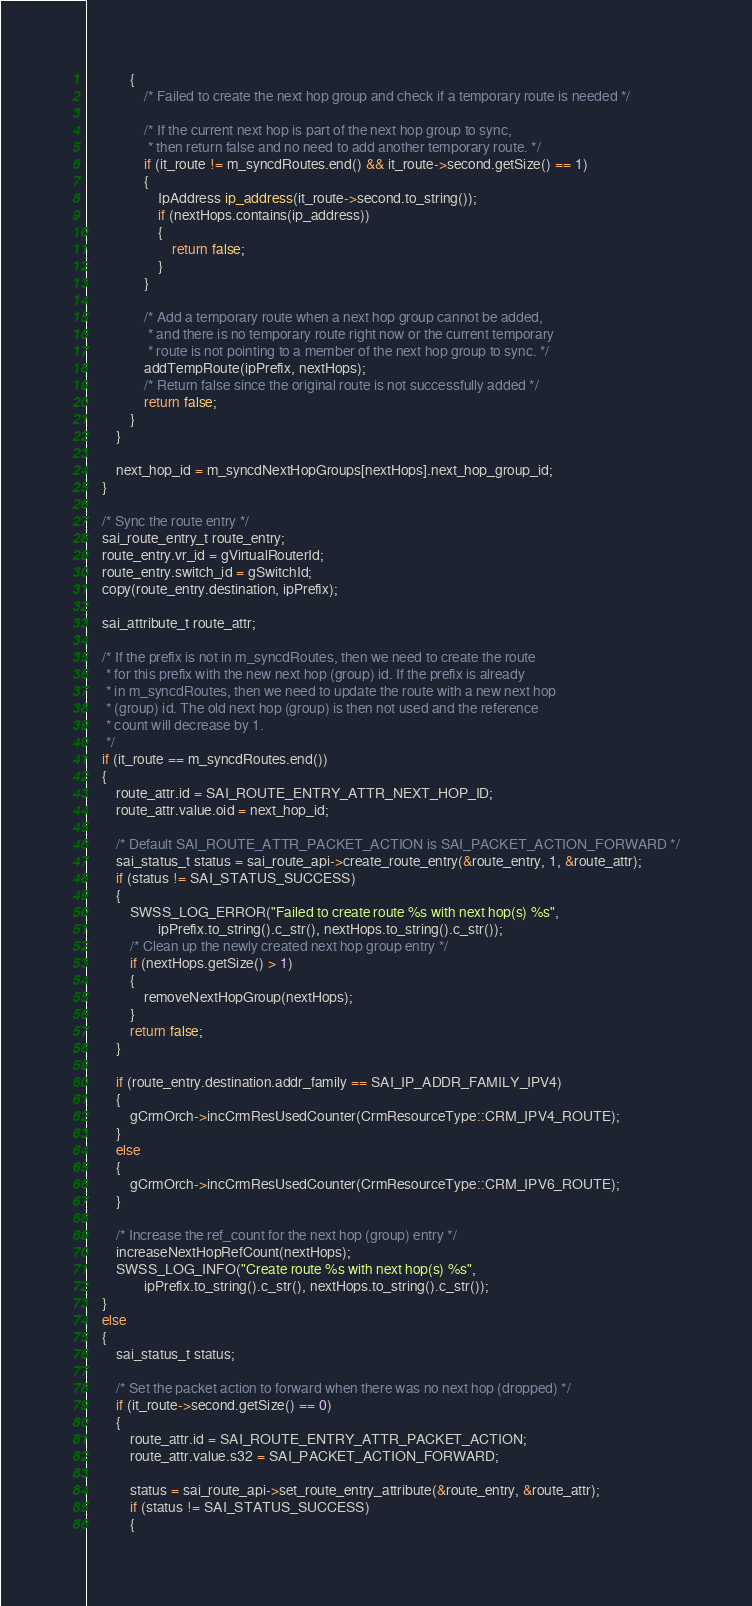Convert code to text. <code><loc_0><loc_0><loc_500><loc_500><_C++_>            {
                /* Failed to create the next hop group and check if a temporary route is needed */

                /* If the current next hop is part of the next hop group to sync,
                 * then return false and no need to add another temporary route. */
                if (it_route != m_syncdRoutes.end() && it_route->second.getSize() == 1)
                {
                    IpAddress ip_address(it_route->second.to_string());
                    if (nextHops.contains(ip_address))
                    {
                        return false;
                    }
                }

                /* Add a temporary route when a next hop group cannot be added,
                 * and there is no temporary route right now or the current temporary
                 * route is not pointing to a member of the next hop group to sync. */
                addTempRoute(ipPrefix, nextHops);
                /* Return false since the original route is not successfully added */
                return false;
            }
        }

        next_hop_id = m_syncdNextHopGroups[nextHops].next_hop_group_id;
    }

    /* Sync the route entry */
    sai_route_entry_t route_entry;
    route_entry.vr_id = gVirtualRouterId;
    route_entry.switch_id = gSwitchId;
    copy(route_entry.destination, ipPrefix);

    sai_attribute_t route_attr;

    /* If the prefix is not in m_syncdRoutes, then we need to create the route
     * for this prefix with the new next hop (group) id. If the prefix is already
     * in m_syncdRoutes, then we need to update the route with a new next hop
     * (group) id. The old next hop (group) is then not used and the reference
     * count will decrease by 1.
     */
    if (it_route == m_syncdRoutes.end())
    {
        route_attr.id = SAI_ROUTE_ENTRY_ATTR_NEXT_HOP_ID;
        route_attr.value.oid = next_hop_id;

        /* Default SAI_ROUTE_ATTR_PACKET_ACTION is SAI_PACKET_ACTION_FORWARD */
        sai_status_t status = sai_route_api->create_route_entry(&route_entry, 1, &route_attr);
        if (status != SAI_STATUS_SUCCESS)
        {
            SWSS_LOG_ERROR("Failed to create route %s with next hop(s) %s",
                    ipPrefix.to_string().c_str(), nextHops.to_string().c_str());
            /* Clean up the newly created next hop group entry */
            if (nextHops.getSize() > 1)
            {
                removeNextHopGroup(nextHops);
            }
            return false;
        }

        if (route_entry.destination.addr_family == SAI_IP_ADDR_FAMILY_IPV4)
        {
            gCrmOrch->incCrmResUsedCounter(CrmResourceType::CRM_IPV4_ROUTE);
        }
        else
        {
            gCrmOrch->incCrmResUsedCounter(CrmResourceType::CRM_IPV6_ROUTE);
        }

        /* Increase the ref_count for the next hop (group) entry */
        increaseNextHopRefCount(nextHops);
        SWSS_LOG_INFO("Create route %s with next hop(s) %s",
                ipPrefix.to_string().c_str(), nextHops.to_string().c_str());
    }
    else
    {
        sai_status_t status;

        /* Set the packet action to forward when there was no next hop (dropped) */
        if (it_route->second.getSize() == 0)
        {
            route_attr.id = SAI_ROUTE_ENTRY_ATTR_PACKET_ACTION;
            route_attr.value.s32 = SAI_PACKET_ACTION_FORWARD;

            status = sai_route_api->set_route_entry_attribute(&route_entry, &route_attr);
            if (status != SAI_STATUS_SUCCESS)
            {</code> 